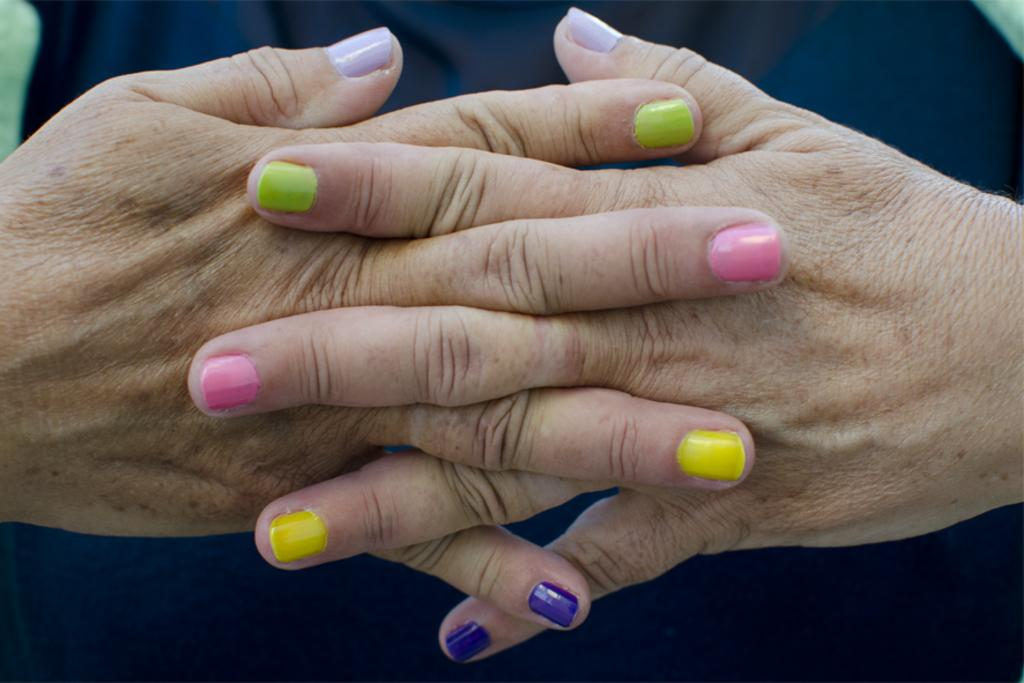How many hands are visible in the image? There are two hands in the image. What can be observed about the nails on the hands? The nails on the hands have different colors of nail polish. What specific nail polish colors can be seen on the hands? The nail polish colors include green, pink, yellow, and violet. What type of houses are depicted in the image? There are no houses present in the image; it features two hands with different colors of nail polish. What type of legal advice can be obtained from the hands in the image? The hands in the image are not providing legal advice, as they are simply displaying different colors of nail polish. 